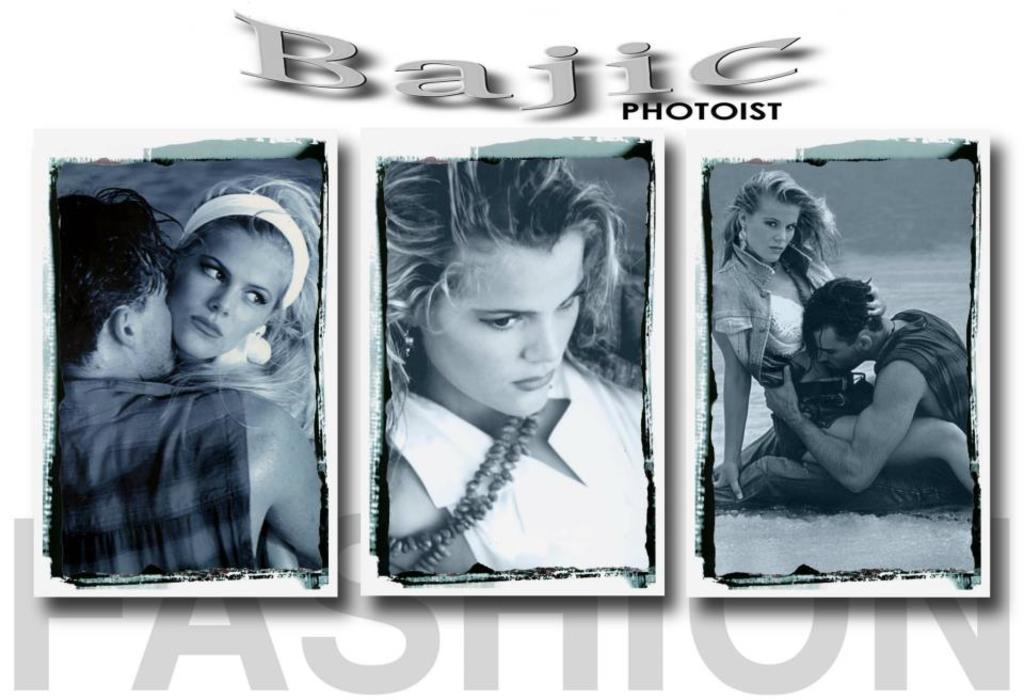In one or two sentences, can you explain what this image depicts? There are three photos,in these photos we can see persons and we can see text. 